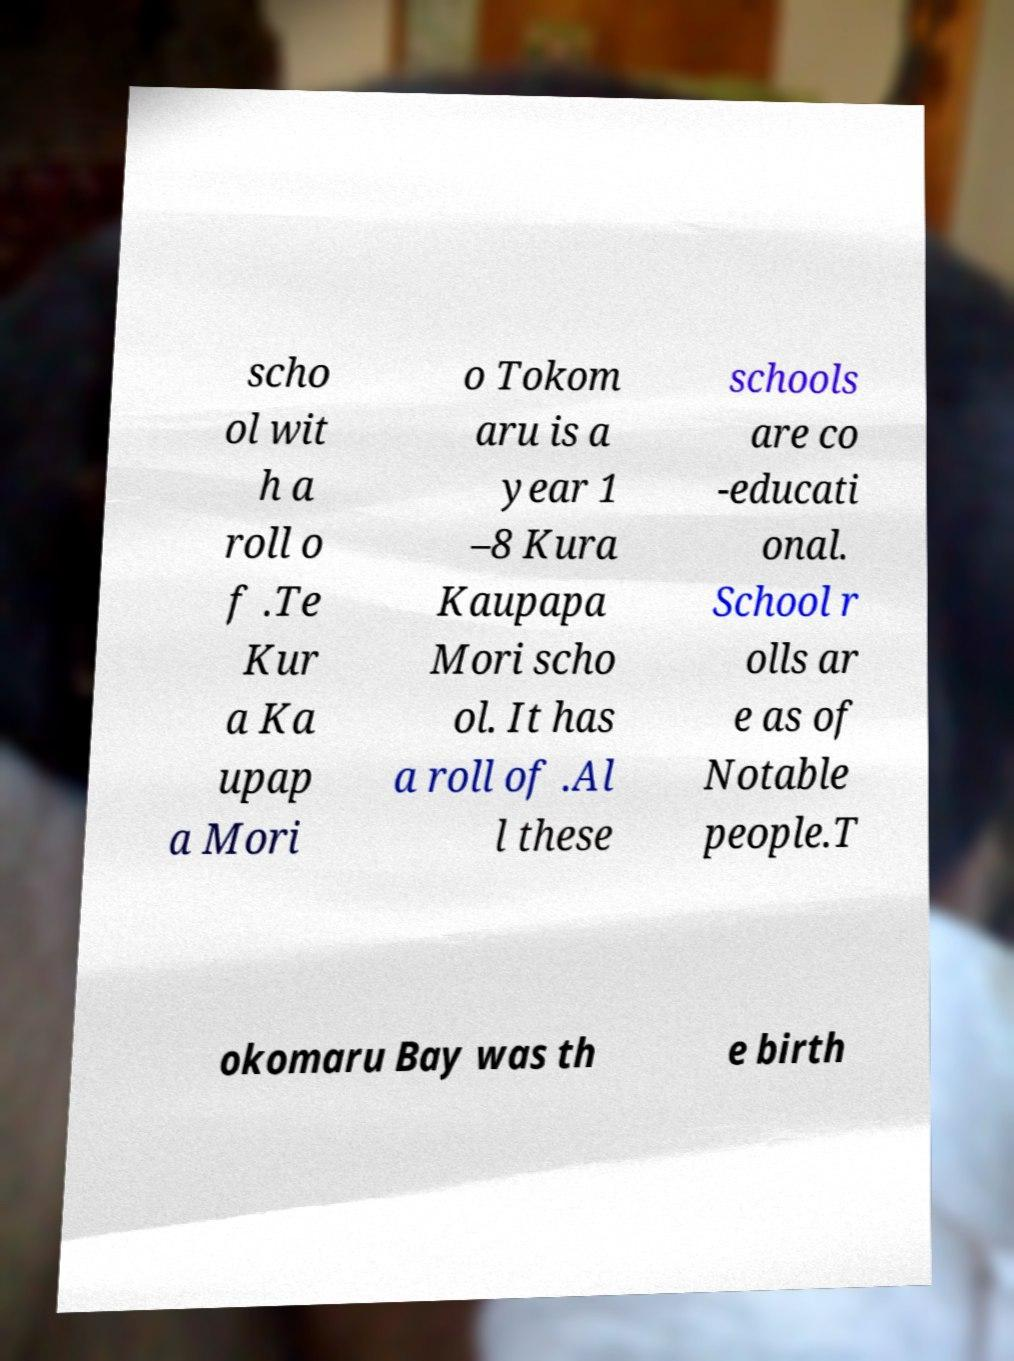Please read and relay the text visible in this image. What does it say? scho ol wit h a roll o f .Te Kur a Ka upap a Mori o Tokom aru is a year 1 –8 Kura Kaupapa Mori scho ol. It has a roll of .Al l these schools are co -educati onal. School r olls ar e as of Notable people.T okomaru Bay was th e birth 